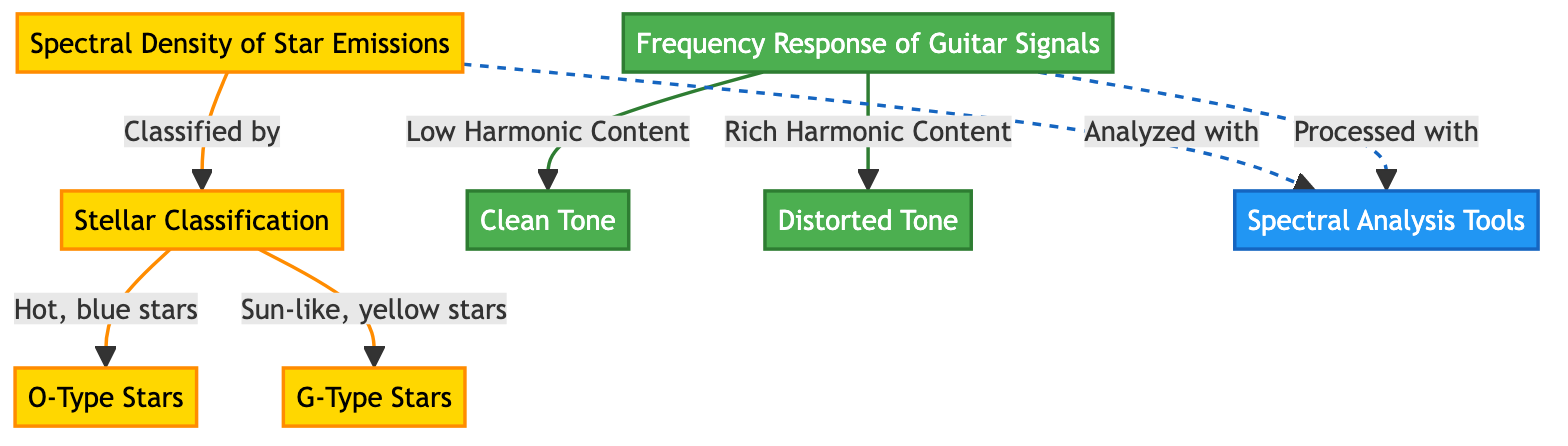What is the main topic of the diagram? The first node, labeled "Spectral Density of Star Emissions," indicates that this is the main subject of the diagram.
Answer: Spectral Density of Star Emissions How many types of stars are classified? The node "Stellar Classification" has two outgoing links leading to "O-Type Stars" and "G-Type Stars," indicating two classifications.
Answer: 2 What kind of tone does "Clean Tone" indicate? The "Clean Tone" node is connected to the "Frequency Response of Guitar Signals" node, indicating it is a type of tonal characteristic associated with guitar signals with low harmonic content.
Answer: Low Harmonic Content Which type of stars are hot and blue? The diagram shows that "O-Type Stars" are classified under "Hot, blue stars," indicating they fall into this category.
Answer: O-Type Stars Which tools are used for analyzing both stellar emissions and guitar signals? The diagram links both "Spectral Density of Star Emissions" and "Frequency Response of Guitar Signals" to the "Spectral Analysis Tools" node, indicating that these tools are applicable to both domains.
Answer: Spectral Analysis Tools What differentiates "Clean Tone" from "Distorted Tone"? The diagram indicates that "Clean Tone" has a relationship with "Low Harmonic Content," while "Distorted Tone" has a relationship with "Rich Harmonic Content," showing the distinction between their harmonic profiles.
Answer: Harmonic Content What is the relationship between stellar classifications and guitar signals? The nodes representing stellar classifications and guitar signals are linked to spectral analysis tools, showing a cross-disciplinary approach in the study of both star emissions and guitar tones.
Answer: Analyzed with Spectral Analysis Tools How are "O-Type Stars" and "G-Type Stars" visually represented in the diagram? "O-Type Stars" are classified as hot, blue stars, while "G-Type Stars" are sun-like, yellow stars, and both are color-coded accordingly under the "Stellar Classification" node.
Answer: Color-coded nodes What is the significance of the dashed lines in the diagram? The dashed lines indicate a different type of connection between the "Spectral Density of Star Emissions" and "Frequency Response of Guitar Signals" with the "Spectral Analysis Tools," signaling that they are processed in a different manner.
Answer: Different processing connection 